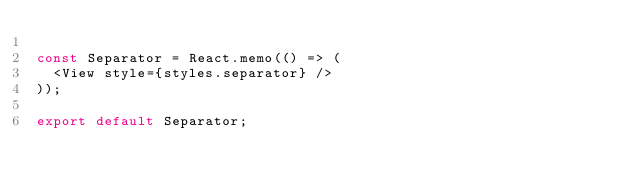Convert code to text. <code><loc_0><loc_0><loc_500><loc_500><_JavaScript_>
const Separator = React.memo(() => (
  <View style={styles.separator} />
));

export default Separator;
</code> 